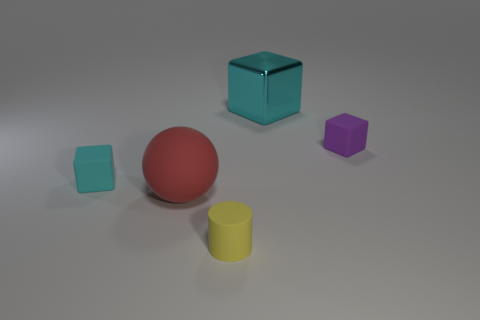Are any small purple rubber cubes visible?
Keep it short and to the point. Yes. What is the material of the block that is the same color as the large shiny object?
Give a very brief answer. Rubber. What number of objects are either cyan metallic blocks or small things?
Provide a short and direct response. 4. Is there a tiny thing of the same color as the cylinder?
Your response must be concise. No. What number of red objects are on the left side of the tiny cube on the right side of the large cube?
Provide a short and direct response. 1. Is the number of small red metallic blocks greater than the number of matte cubes?
Your answer should be very brief. No. Is the large cyan thing made of the same material as the red sphere?
Ensure brevity in your answer.  No. Are there an equal number of tiny things that are to the left of the large red rubber sphere and big cyan matte cylinders?
Your answer should be compact. No. How many other red spheres have the same material as the large red sphere?
Your answer should be compact. 0. Are there fewer small gray things than cylinders?
Keep it short and to the point. Yes. 